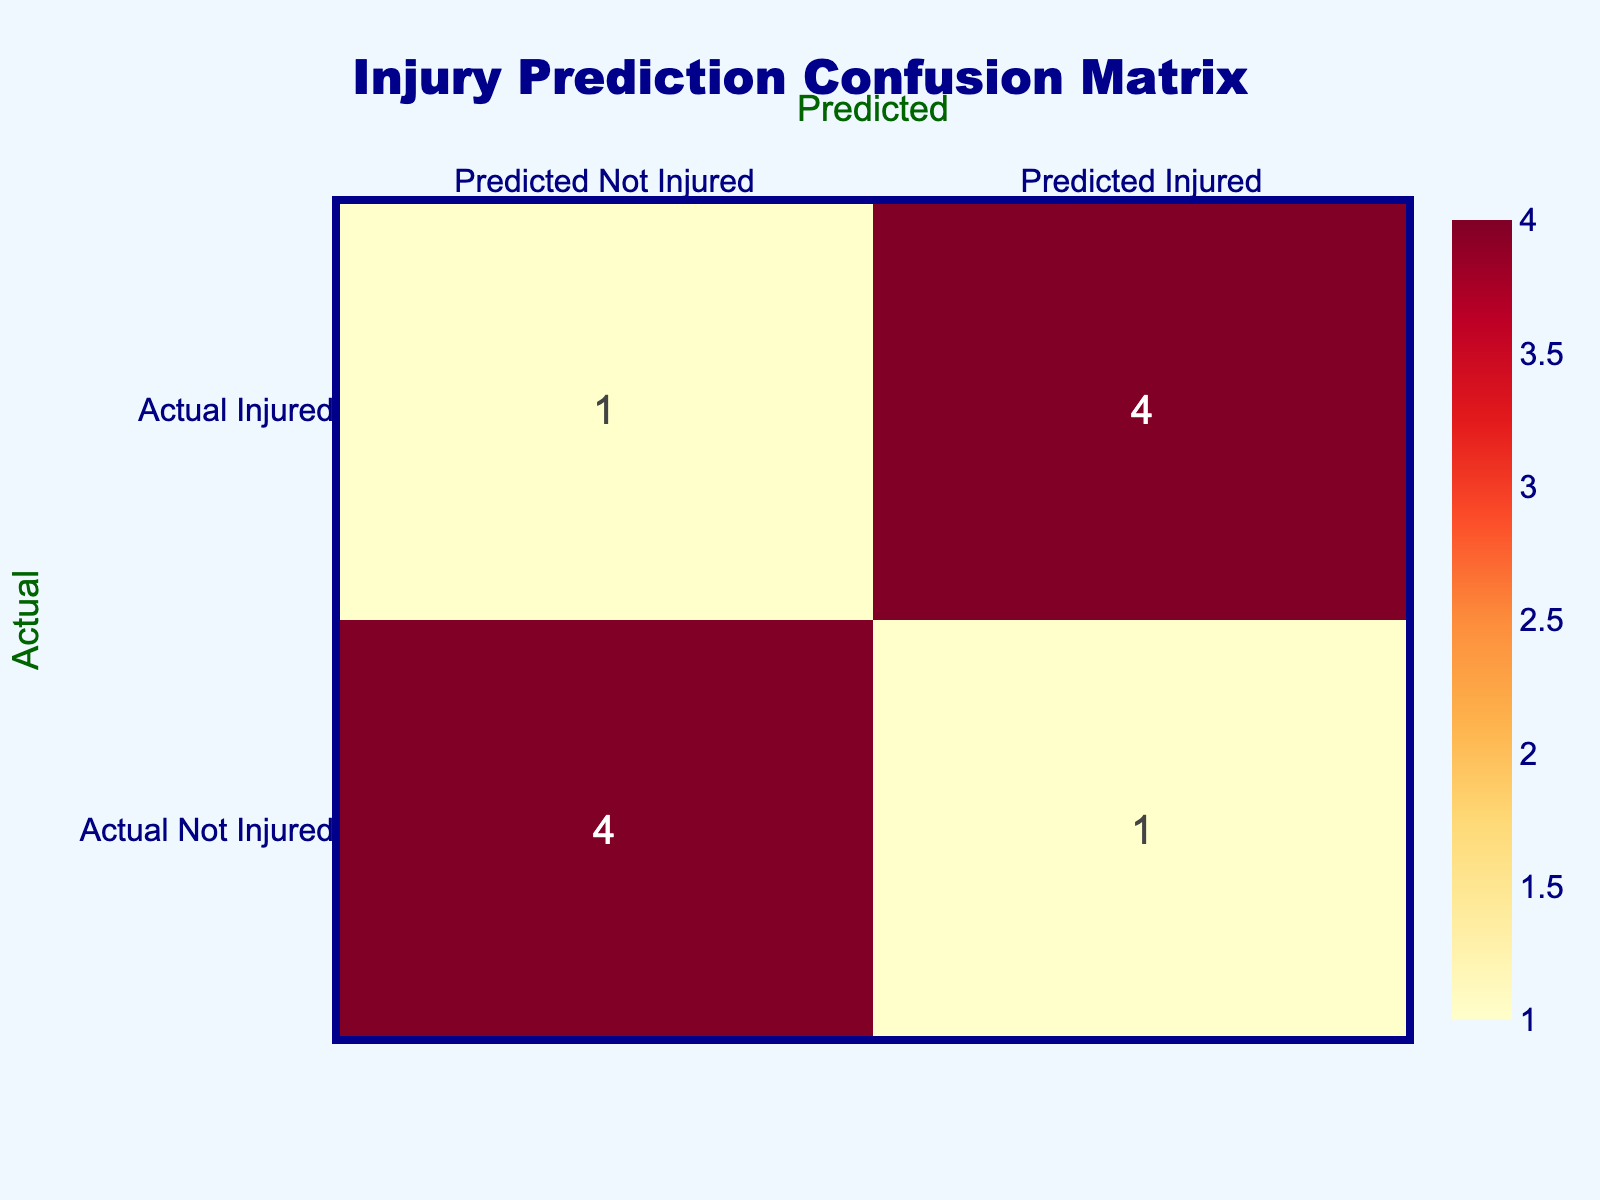What is the total number of players predicted to be injured? There are 5 players predicted to be injured: Josh Woods, Mike Thompson, James Anderson, Lucas White, and Daniel Lee.
Answer: 5 What percentage of players that were actually injured were predicted to be injured? 5 players were actually injured, and out of them, 4 were predicted to be injured. To find the percentage: (4/5)*100 = 80%.
Answer: 80% Is it true that all players who had a high training load were predicted to be injured? No, not all players with a high training load were predicted to be injured. James Anderson had a high training load but was predicted to be not injured.
Answer: No How many players with a medium injury risk were predicted to be injured? There is 1 player (Kyle Wilson) with a medium injury risk who is predicted to be injured.
Answer: 1 If we combine the numbers of players predicted to be not injured and actually not injured, what is the total? There are 3 players predicted to be not injured (David Johnson, Ethan Brown, Ryan Smith) and 4 players actually not injured (David Johnson, Ethan Brown, Ryan Smith, Samuel Green). The total is 3 + 4 = 7.
Answer: 7 What is the difference in the number of players actually injured versus predicted injured? There are 5 players actually injured and 4 players predicted injured. The difference is 5 - 4 = 1.
Answer: 1 Are there any players with previous injuries that were predicted to be not injured? Yes, James Anderson had 0 previous injuries and was predicted to be not injured, thus indicating a discrepancy between prediction and injury history.
Answer: Yes How many players with a previous injury had a high training load and were predicted to be injured? There are 3 players with a high training load and previous injuries (Josh Woods, Mike Thompson, Daniel Lee) and all were predicted to be injured.
Answer: 3 